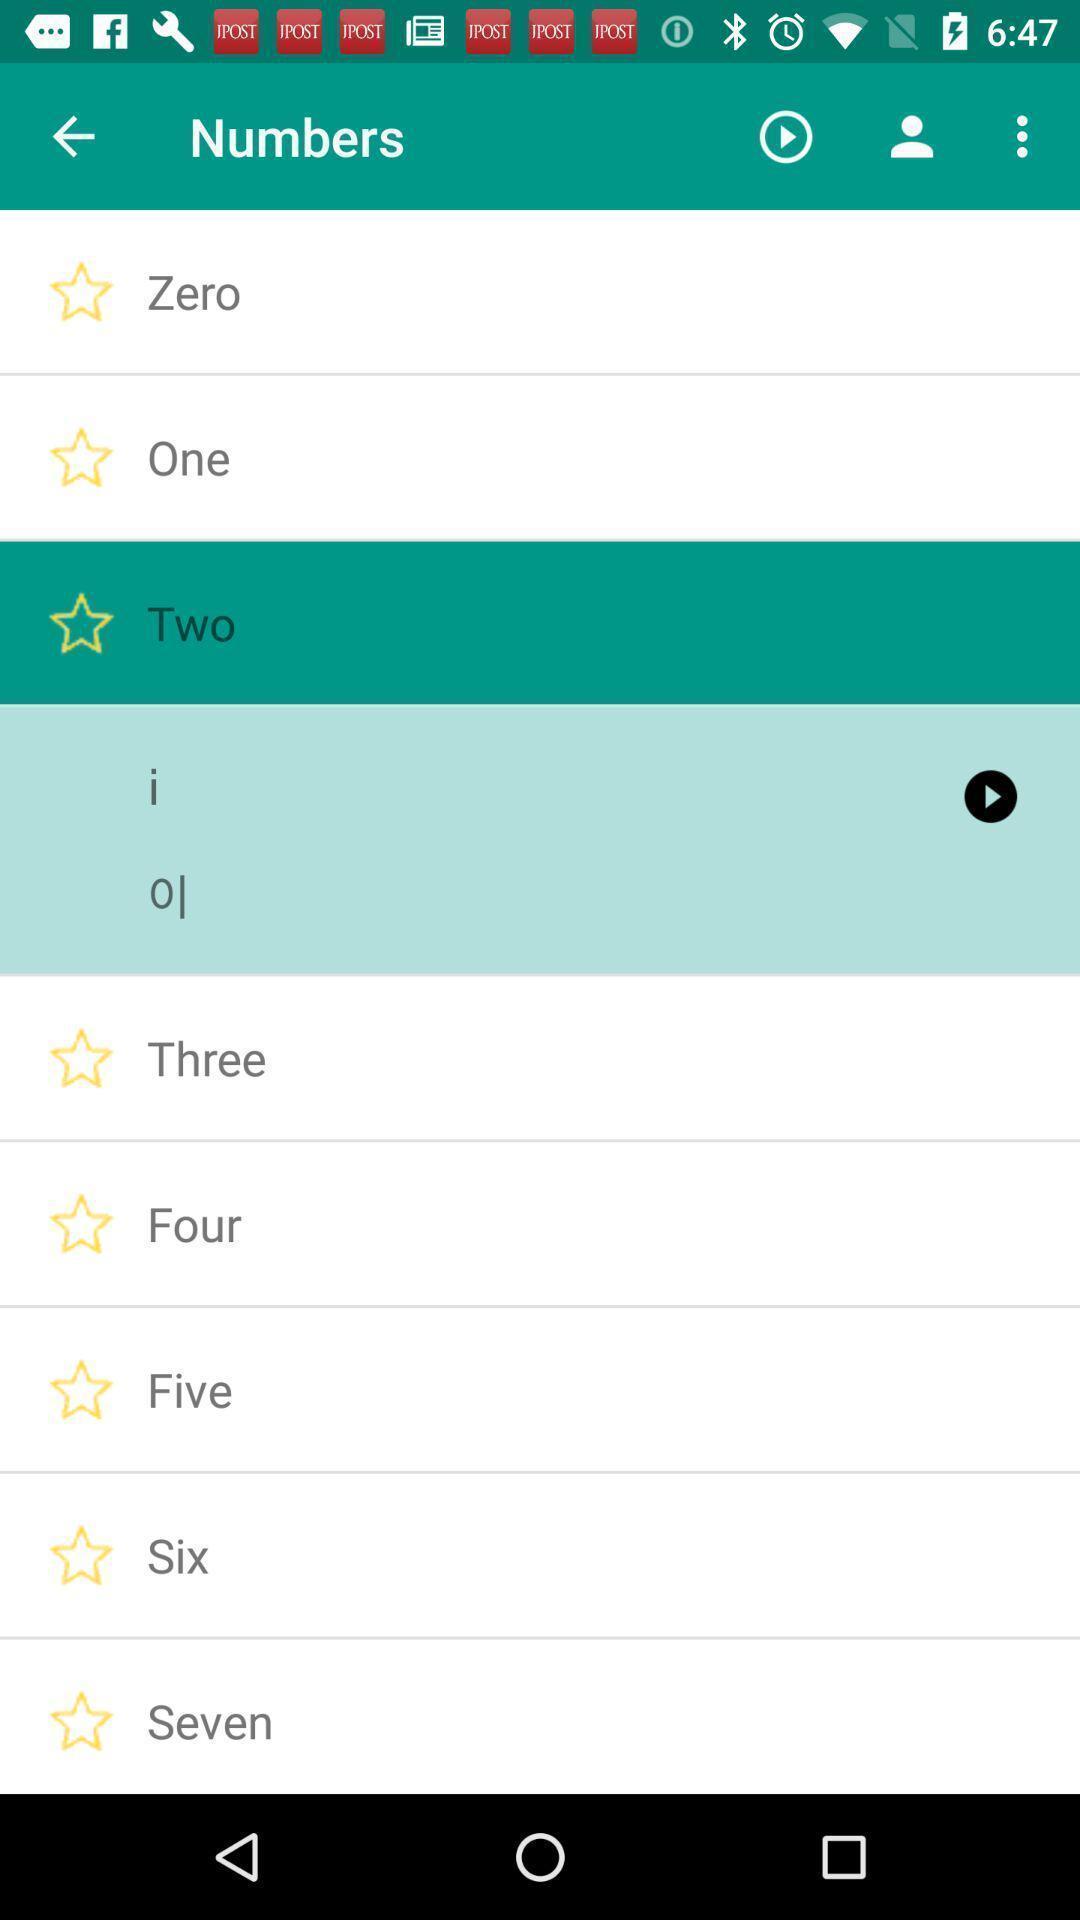Describe the key features of this screenshot. Page showing the numbers listings. 